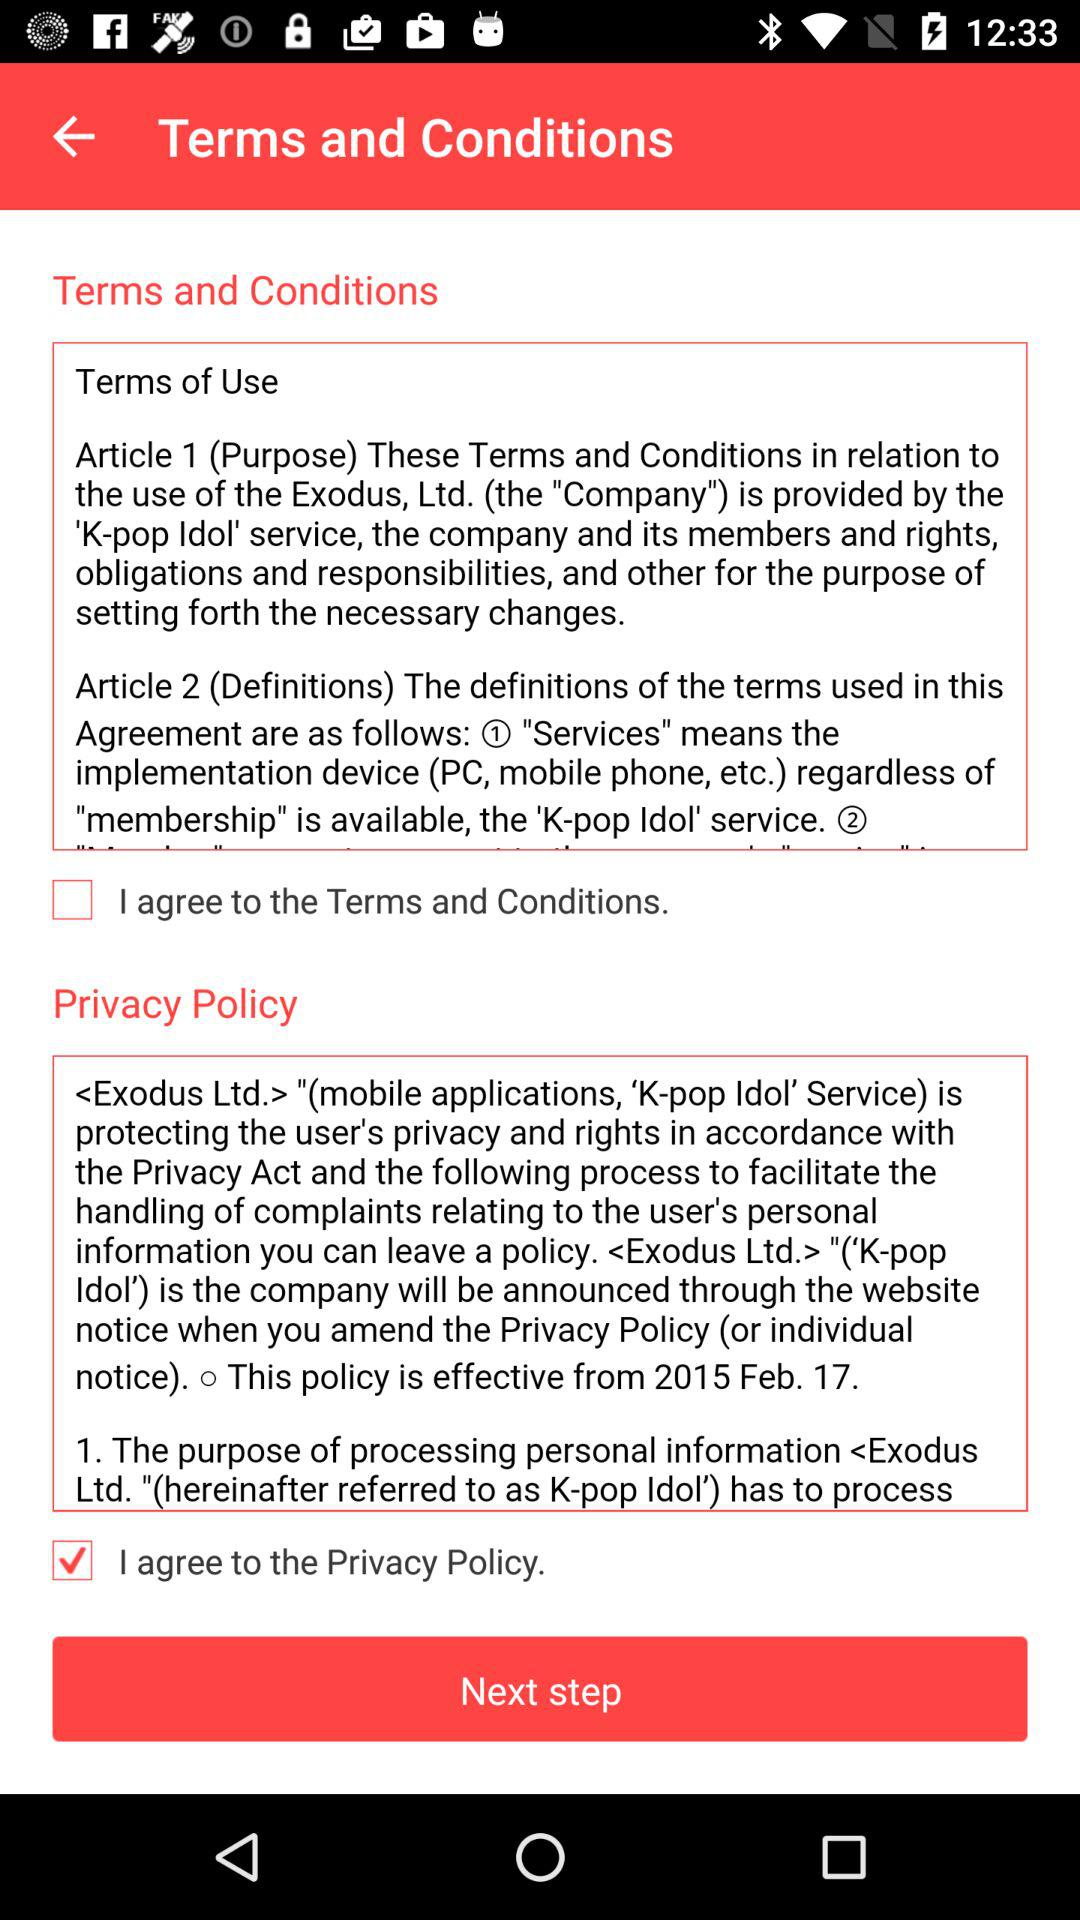What is the status of "I agree to the Terms and Conditions"? The status is "off". 